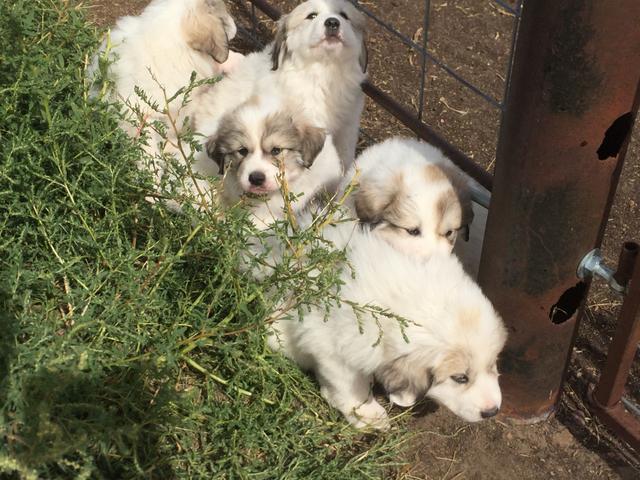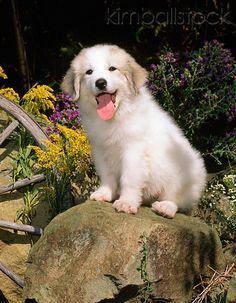The first image is the image on the left, the second image is the image on the right. Given the left and right images, does the statement "There are at most two dogs." hold true? Answer yes or no. No. The first image is the image on the left, the second image is the image on the right. Analyze the images presented: Is the assertion "One image shows a single sitting white dog, and the other image contains multiple white dogs that are all puppies." valid? Answer yes or no. Yes. 